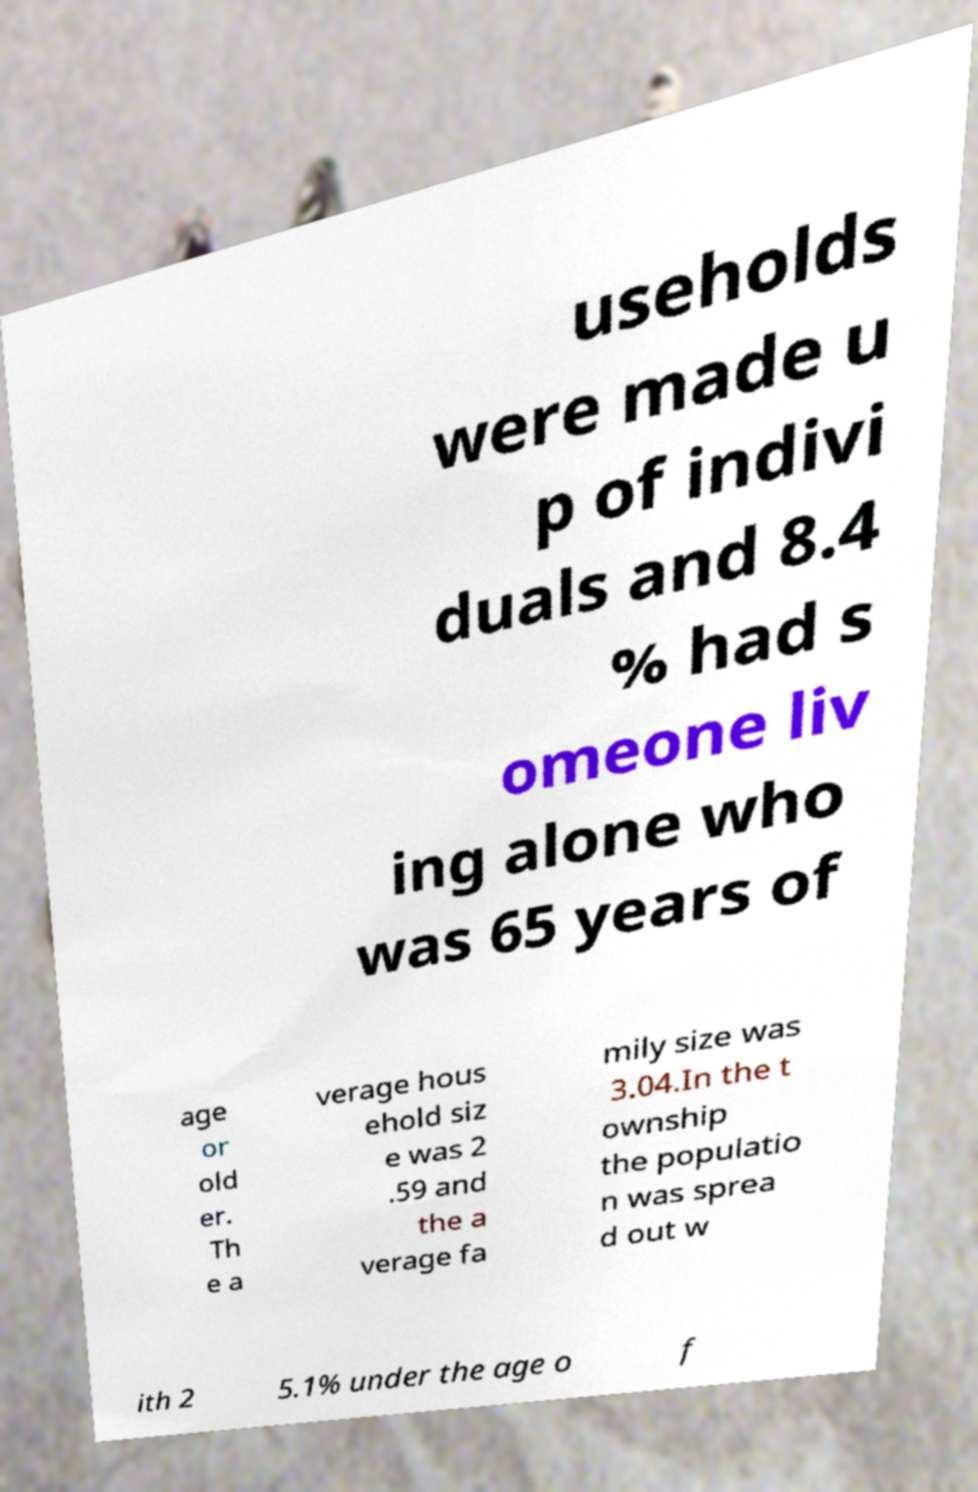I need the written content from this picture converted into text. Can you do that? useholds were made u p of indivi duals and 8.4 % had s omeone liv ing alone who was 65 years of age or old er. Th e a verage hous ehold siz e was 2 .59 and the a verage fa mily size was 3.04.In the t ownship the populatio n was sprea d out w ith 2 5.1% under the age o f 